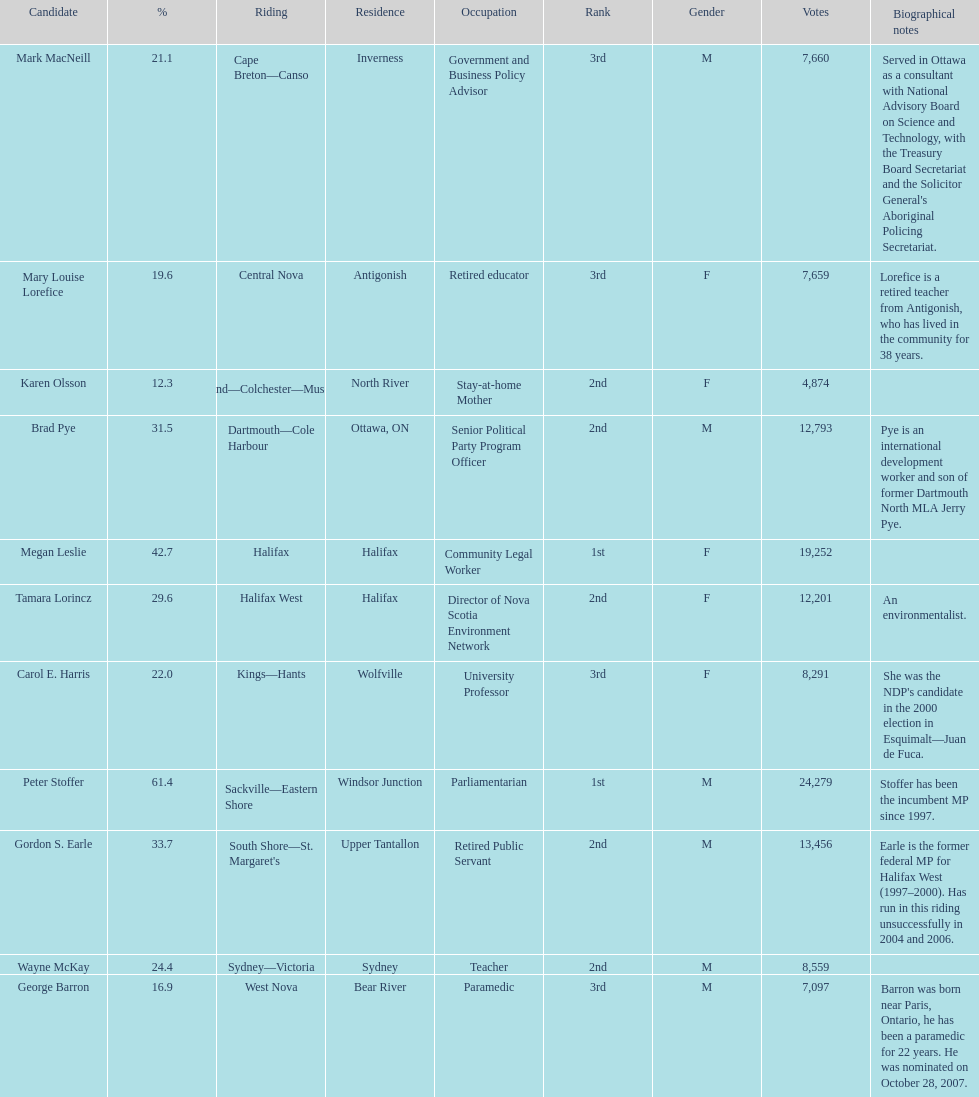What is the first riding? Cape Breton-Canso. 